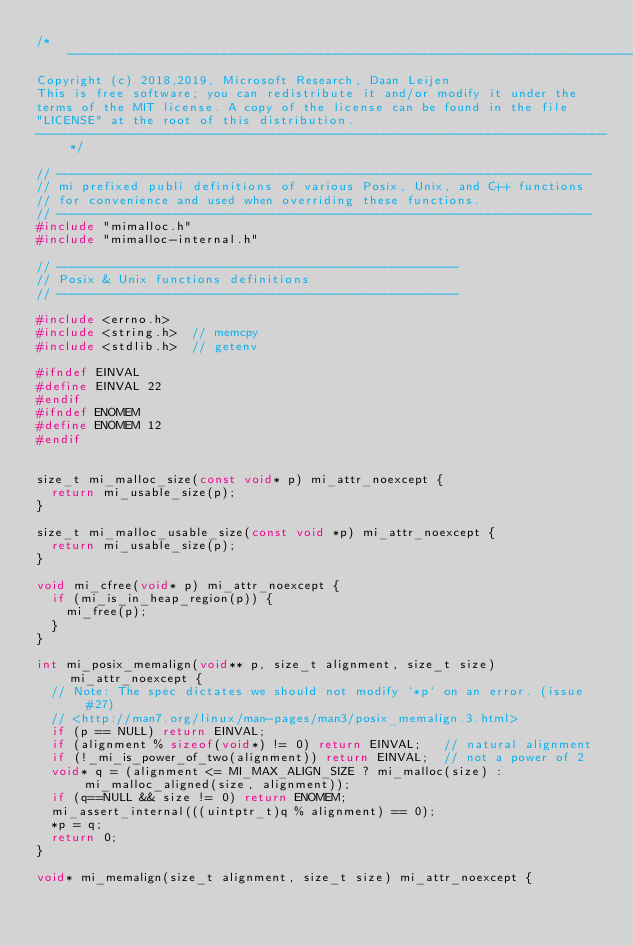<code> <loc_0><loc_0><loc_500><loc_500><_C_>/* ----------------------------------------------------------------------------
Copyright (c) 2018,2019, Microsoft Research, Daan Leijen
This is free software; you can redistribute it and/or modify it under the
terms of the MIT license. A copy of the license can be found in the file
"LICENSE" at the root of this distribution.
-----------------------------------------------------------------------------*/

// ------------------------------------------------------------------------
// mi prefixed publi definitions of various Posix, Unix, and C++ functions
// for convenience and used when overriding these functions.
// ------------------------------------------------------------------------
#include "mimalloc.h"
#include "mimalloc-internal.h"

// ------------------------------------------------------
// Posix & Unix functions definitions
// ------------------------------------------------------

#include <errno.h>
#include <string.h>  // memcpy
#include <stdlib.h>  // getenv

#ifndef EINVAL
#define EINVAL 22
#endif
#ifndef ENOMEM
#define ENOMEM 12
#endif


size_t mi_malloc_size(const void* p) mi_attr_noexcept {
  return mi_usable_size(p);
}

size_t mi_malloc_usable_size(const void *p) mi_attr_noexcept {
  return mi_usable_size(p);
}

void mi_cfree(void* p) mi_attr_noexcept {
  if (mi_is_in_heap_region(p)) {
    mi_free(p);
  }
}

int mi_posix_memalign(void** p, size_t alignment, size_t size) mi_attr_noexcept {
  // Note: The spec dictates we should not modify `*p` on an error. (issue#27)
  // <http://man7.org/linux/man-pages/man3/posix_memalign.3.html>
  if (p == NULL) return EINVAL;
  if (alignment % sizeof(void*) != 0) return EINVAL;   // natural alignment
  if (!_mi_is_power_of_two(alignment)) return EINVAL;  // not a power of 2
  void* q = (alignment <= MI_MAX_ALIGN_SIZE ? mi_malloc(size) : mi_malloc_aligned(size, alignment));
  if (q==NULL && size != 0) return ENOMEM;
  mi_assert_internal(((uintptr_t)q % alignment) == 0);
  *p = q;
  return 0;
}

void* mi_memalign(size_t alignment, size_t size) mi_attr_noexcept {</code> 